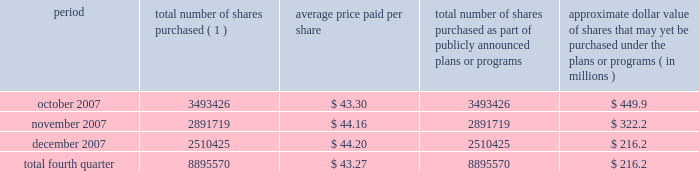Issuer purchases of equity securities during the three months ended december 31 , 2007 , we repurchased 8895570 shares of our class a common stock for an aggregate of $ 385.1 million pursuant to the $ 1.5 billion stock repurchase program publicly announced in february 2007 , as follows : period total number of shares purchased ( 1 ) average price paid per share total number of shares purchased as part of publicly announced plans or programs approximate dollar value of shares that may yet be purchased under the plans or programs ( in millions ) .
( 1 ) issuer repurchases pursuant to the $ 1.5 billion stock repurchase program publicly announced in february 2007 .
Under this program , our management was authorized through february 2008 to purchase shares from time to time through open market purchases or privately negotiated transactions at prevailing prices as permitted by securities laws and other legal requirements , and subject to market conditions and other factors .
To facilitate repurchases , we typically made purchases pursuant to trading plans under rule 10b5-1 of the exchange act , which allow us to repurchase shares during periods when we otherwise might be prevented from doing so under insider trading laws or because of self-imposed trading blackout periods .
Subsequent to december 31 , 2007 , we repurchased 4.3 million shares of our class a common stock for an aggregate of $ 163.7 million pursuant to this program .
In february 2008 , our board of directors approved a new stock repurchase program , pursuant to which we are authorized to purchase up to an additional $ 1.5 billion of our class a common stock .
Purchases under this stock repurchase program are subject to us having available cash to fund repurchases , as further described in item 1a of this annual report under the caption 201crisk factors 2014we anticipate that we may need additional financing to fund our stock repurchase programs , to refinance our existing indebtedness and to fund future growth and expansion initiatives 201d and item 7 of this annual report under the caption 201cmanagement 2019s discussion and analysis of financial condition and results of operations 2014liquidity and capital resources . 201d .
What is the total amount spent for stock repurchase during october 2007 , in millions? 
Computations: ((3493426 * 43.30) / 1000000)
Answer: 151.26535. 